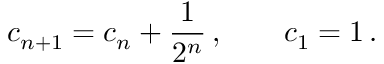Convert formula to latex. <formula><loc_0><loc_0><loc_500><loc_500>c _ { n + 1 } = c _ { n } + \frac { 1 } { 2 ^ { n } } \, , \quad c _ { 1 } = 1 \, .</formula> 